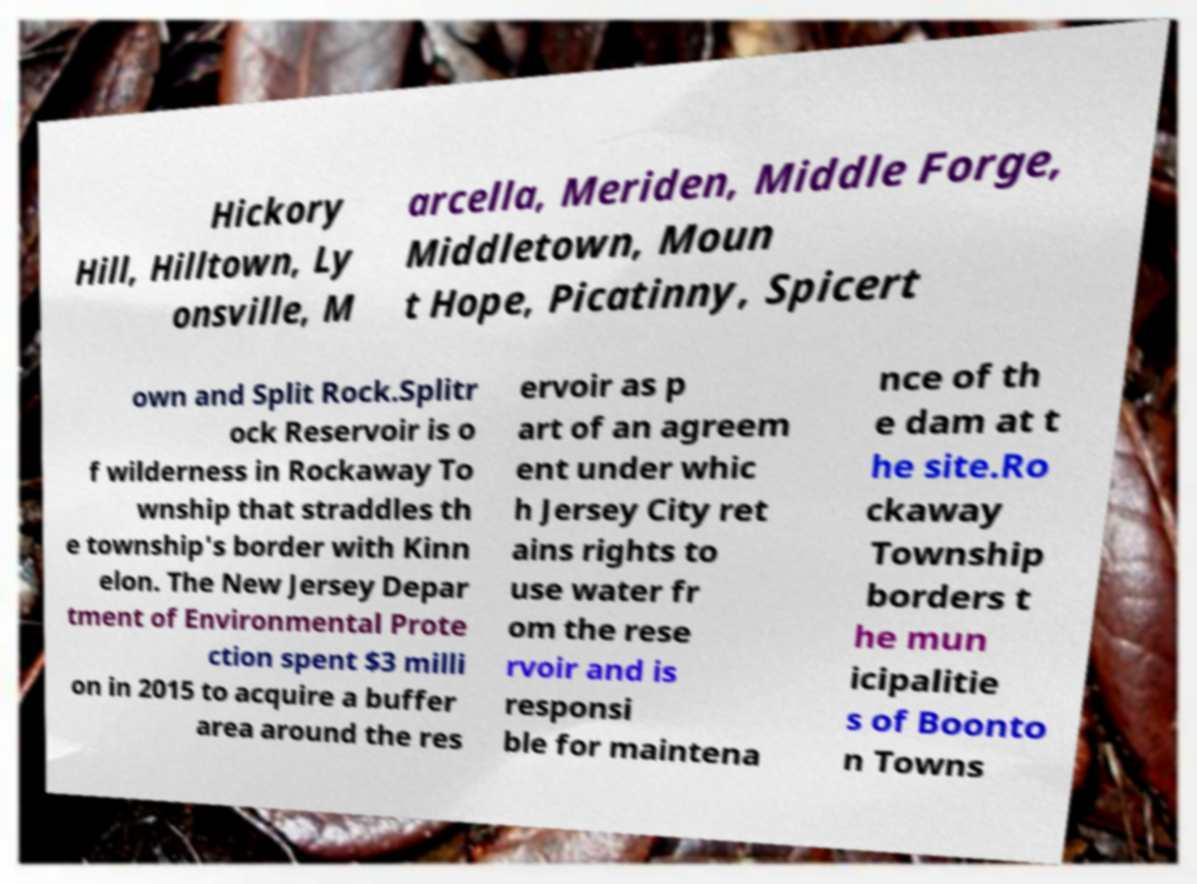Please identify and transcribe the text found in this image. Hickory Hill, Hilltown, Ly onsville, M arcella, Meriden, Middle Forge, Middletown, Moun t Hope, Picatinny, Spicert own and Split Rock.Splitr ock Reservoir is o f wilderness in Rockaway To wnship that straddles th e township's border with Kinn elon. The New Jersey Depar tment of Environmental Prote ction spent $3 milli on in 2015 to acquire a buffer area around the res ervoir as p art of an agreem ent under whic h Jersey City ret ains rights to use water fr om the rese rvoir and is responsi ble for maintena nce of th e dam at t he site.Ro ckaway Township borders t he mun icipalitie s of Boonto n Towns 